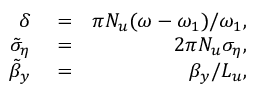Convert formula to latex. <formula><loc_0><loc_0><loc_500><loc_500>\begin{array} { r l r } { \delta } & = } & { \pi N _ { u } ( \omega - \omega _ { 1 } ) / \omega _ { 1 } , } \\ { \tilde { \sigma } _ { \eta } } & = } & { 2 \pi N _ { u } \sigma _ { \eta } , } \\ { \tilde { \beta } _ { y } } & = } & { \beta _ { y } / L _ { u } , } \end{array}</formula> 